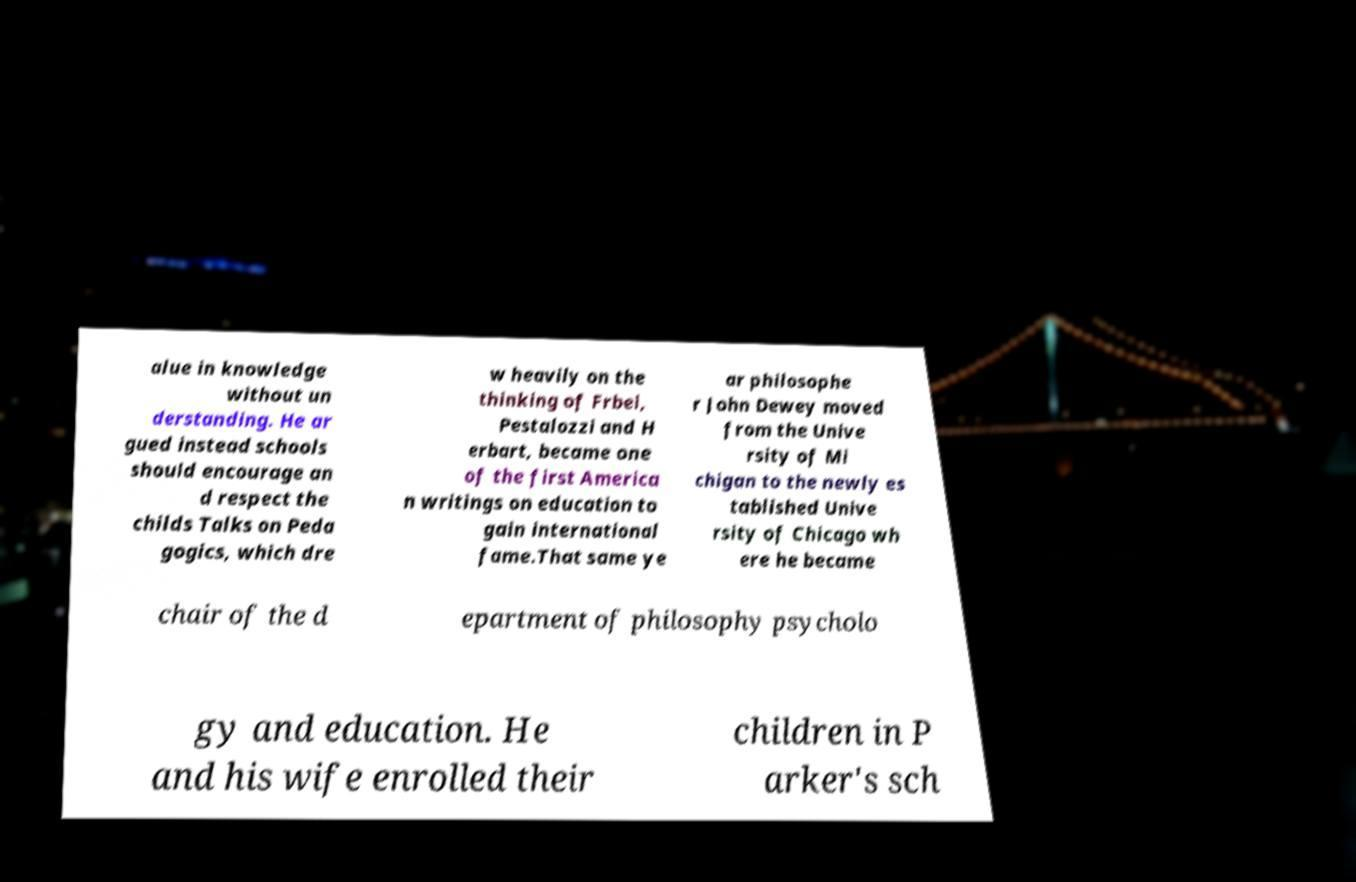Could you extract and type out the text from this image? alue in knowledge without un derstanding. He ar gued instead schools should encourage an d respect the childs Talks on Peda gogics, which dre w heavily on the thinking of Frbel, Pestalozzi and H erbart, became one of the first America n writings on education to gain international fame.That same ye ar philosophe r John Dewey moved from the Unive rsity of Mi chigan to the newly es tablished Unive rsity of Chicago wh ere he became chair of the d epartment of philosophy psycholo gy and education. He and his wife enrolled their children in P arker's sch 